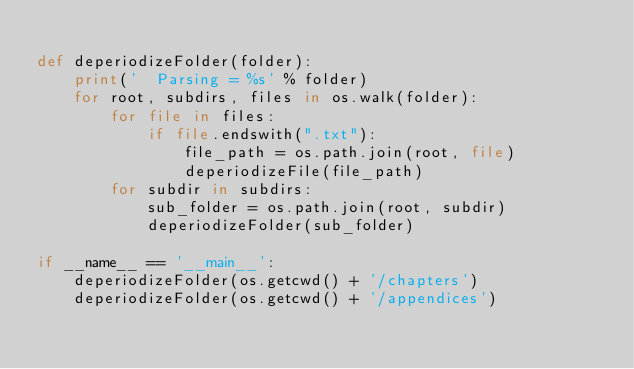Convert code to text. <code><loc_0><loc_0><loc_500><loc_500><_Python_>
def deperiodizeFolder(folder):
    print('  Parsing = %s' % folder)
    for root, subdirs, files in os.walk(folder):
        for file in files:
            if file.endswith(".txt"):
                file_path = os.path.join(root, file)
                deperiodizeFile(file_path)
        for subdir in subdirs:
            sub_folder = os.path.join(root, subdir)
            deperiodizeFolder(sub_folder)

if __name__ == '__main__':
    deperiodizeFolder(os.getcwd() + '/chapters')
    deperiodizeFolder(os.getcwd() + '/appendices')
</code> 